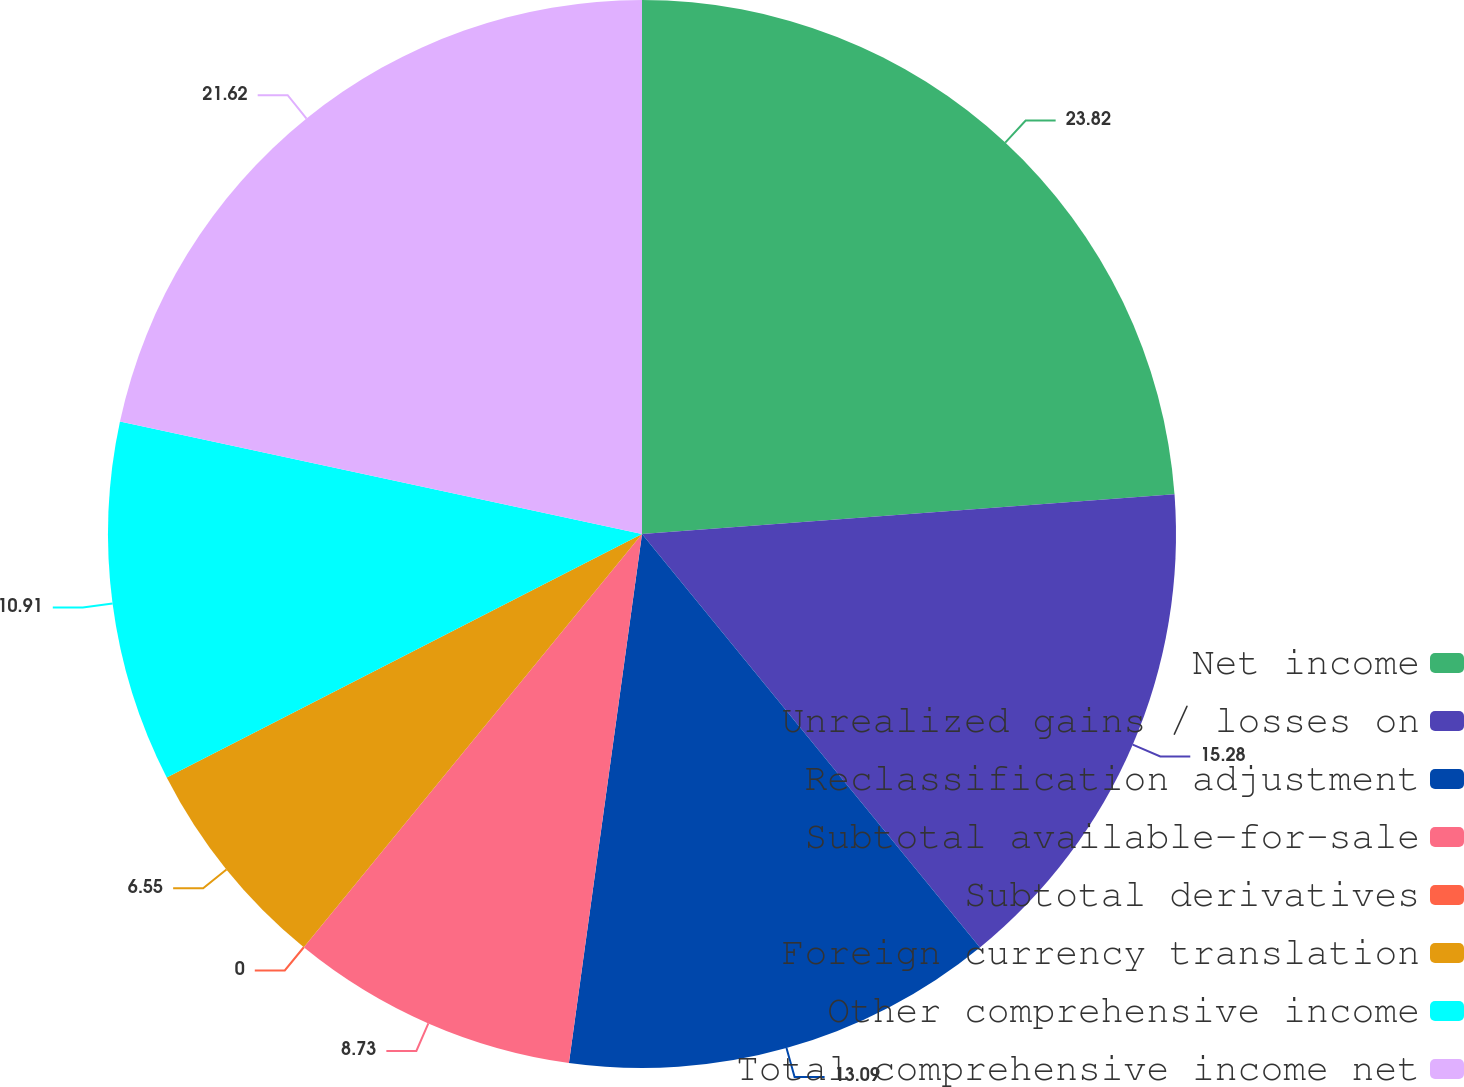Convert chart. <chart><loc_0><loc_0><loc_500><loc_500><pie_chart><fcel>Net income<fcel>Unrealized gains / losses on<fcel>Reclassification adjustment<fcel>Subtotal available-for-sale<fcel>Subtotal derivatives<fcel>Foreign currency translation<fcel>Other comprehensive income<fcel>Total comprehensive income net<nl><fcel>23.81%<fcel>15.28%<fcel>13.09%<fcel>8.73%<fcel>0.0%<fcel>6.55%<fcel>10.91%<fcel>21.62%<nl></chart> 